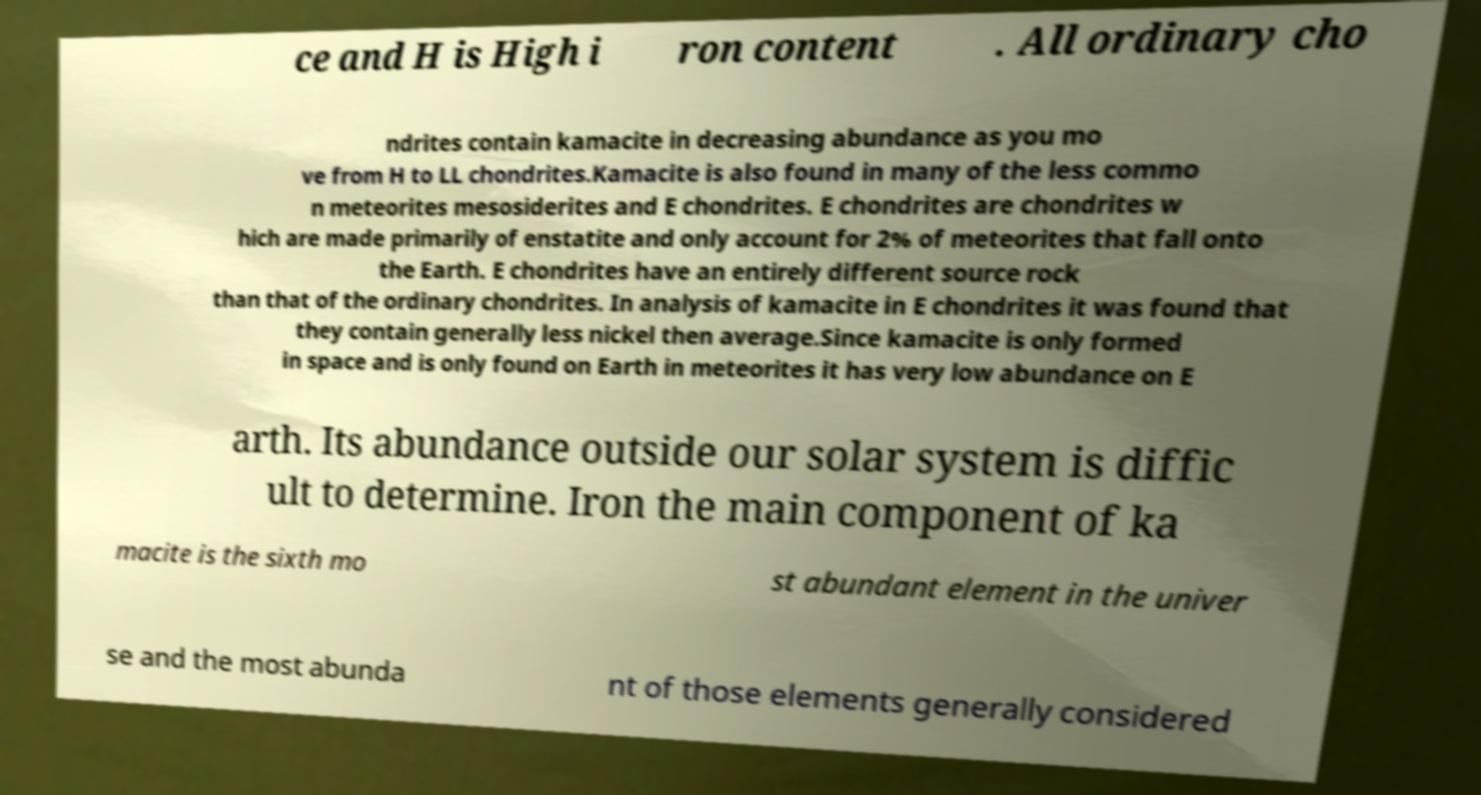There's text embedded in this image that I need extracted. Can you transcribe it verbatim? ce and H is High i ron content . All ordinary cho ndrites contain kamacite in decreasing abundance as you mo ve from H to LL chondrites.Kamacite is also found in many of the less commo n meteorites mesosiderites and E chondrites. E chondrites are chondrites w hich are made primarily of enstatite and only account for 2% of meteorites that fall onto the Earth. E chondrites have an entirely different source rock than that of the ordinary chondrites. In analysis of kamacite in E chondrites it was found that they contain generally less nickel then average.Since kamacite is only formed in space and is only found on Earth in meteorites it has very low abundance on E arth. Its abundance outside our solar system is diffic ult to determine. Iron the main component of ka macite is the sixth mo st abundant element in the univer se and the most abunda nt of those elements generally considered 